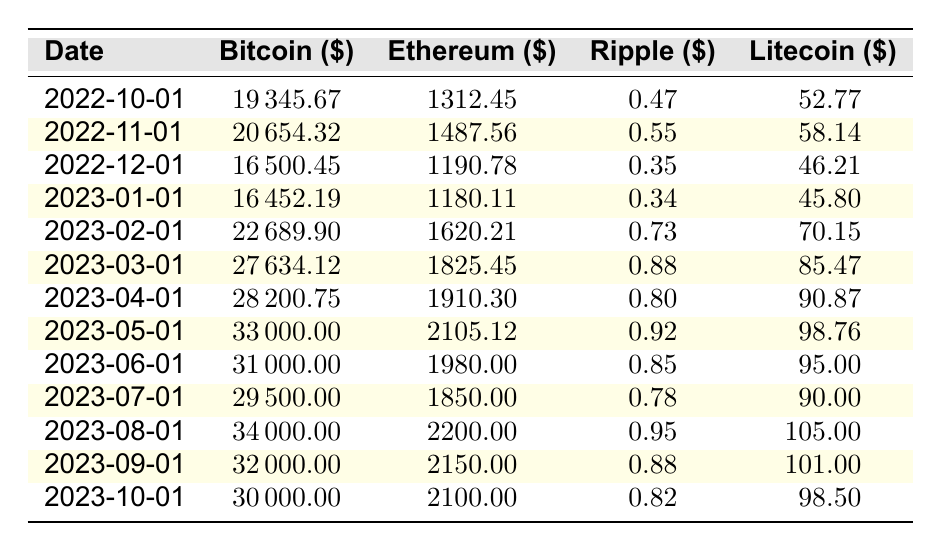What was the price of Bitcoin on February 1, 2023? According to the table, under the date February 1, 2023, the Bitcoin price listed is 22689.90 USD.
Answer: 22689.90 What is the price difference between Ethereum on March 1, 2023, and Ethereum on October 1, 2023? For March 1, 2023, the Ethereum price is 1825.45 USD, and for October 1, 2023, it is 2100.00 USD. Calculating the difference: 2100.00 - 1825.45 = 274.55 USD.
Answer: 274.55 Did the price of Ripple increase from October 2022 to October 2023? On October 1, 2022, the price of Ripple was 0.47 USD, and on October 1, 2023, it is 0.82 USD. Since 0.82 is greater than 0.47, this means that the price increased.
Answer: Yes What was the highest price of Litecoin in this table and when did it occur? The highest price of Litecoin listed is 105.00 USD, which occurred on August 1, 2023.
Answer: 105.00 on August 1, 2023 What is the average price of Bitcoin from January 2023 to March 2023? The prices of Bitcoin for January 2023, February 2023, and March 2023 are 16452.19, 22689.90, and 27634.12 USD respectively. Adding these: 16452.19 + 22689.90 + 27634.12 = 66776.21 USD. Dividing by 3 gives the average: 66776.21 / 3 = 22258.74 USD.
Answer: 22258.74 What was the percentage increase in price of Ethereum from October 2022 to May 2023? The price of Ethereum on October 1, 2022, is 1312.45 USD, and on May 1, 2023, it is 2105.12 USD. The increase is 2105.12 - 1312.45 = 792.67 USD. The percentage increase is (792.67 / 1312.45) * 100 = 60.24%.
Answer: 60.24% Was the Bitcoin price ever below 20000 USD in this period? Reviewing the table, the Bitcoin prices below 20000 USD were recorded on October 1, 2022 (19345.67 USD) and December 1, 2022 (16500.45 USD). Therefore, it is true that Bitcoin price fell below 20000 USD during this period.
Answer: Yes Which month had the highest price for Ethereum? The prices for Ethereum are: February 2023 (1620.21 USD), March 2023 (1825.45 USD), April 2023 (1910.30 USD), May 2023 (2105.12 USD), and the highest among them is 2105.12 USD in May 2023.
Answer: May 2023 